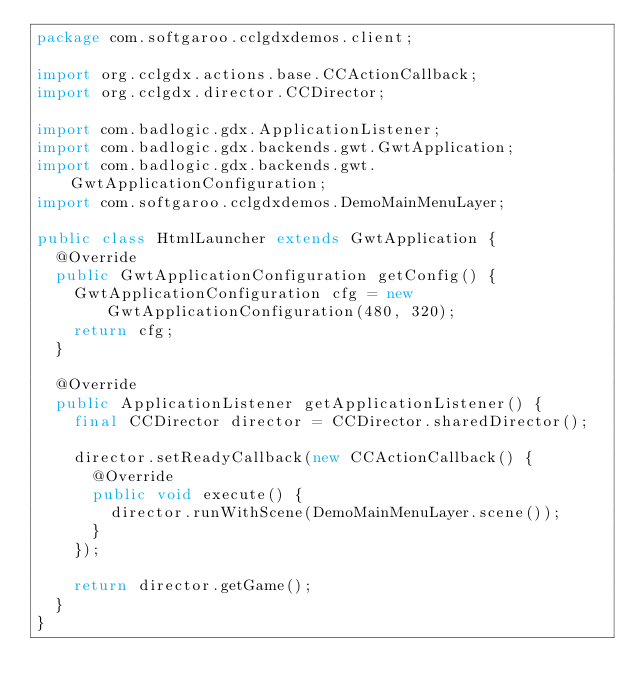<code> <loc_0><loc_0><loc_500><loc_500><_Java_>package com.softgaroo.cclgdxdemos.client;

import org.cclgdx.actions.base.CCActionCallback;
import org.cclgdx.director.CCDirector;

import com.badlogic.gdx.ApplicationListener;
import com.badlogic.gdx.backends.gwt.GwtApplication;
import com.badlogic.gdx.backends.gwt.GwtApplicationConfiguration;
import com.softgaroo.cclgdxdemos.DemoMainMenuLayer;

public class HtmlLauncher extends GwtApplication {
	@Override
	public GwtApplicationConfiguration getConfig() {
		GwtApplicationConfiguration cfg = new GwtApplicationConfiguration(480, 320);
		return cfg;
	}

	@Override
	public ApplicationListener getApplicationListener() {
		final CCDirector director = CCDirector.sharedDirector();

		director.setReadyCallback(new CCActionCallback() {
			@Override
			public void execute() {
				director.runWithScene(DemoMainMenuLayer.scene());
			}
		});

		return director.getGame();
	}
}</code> 